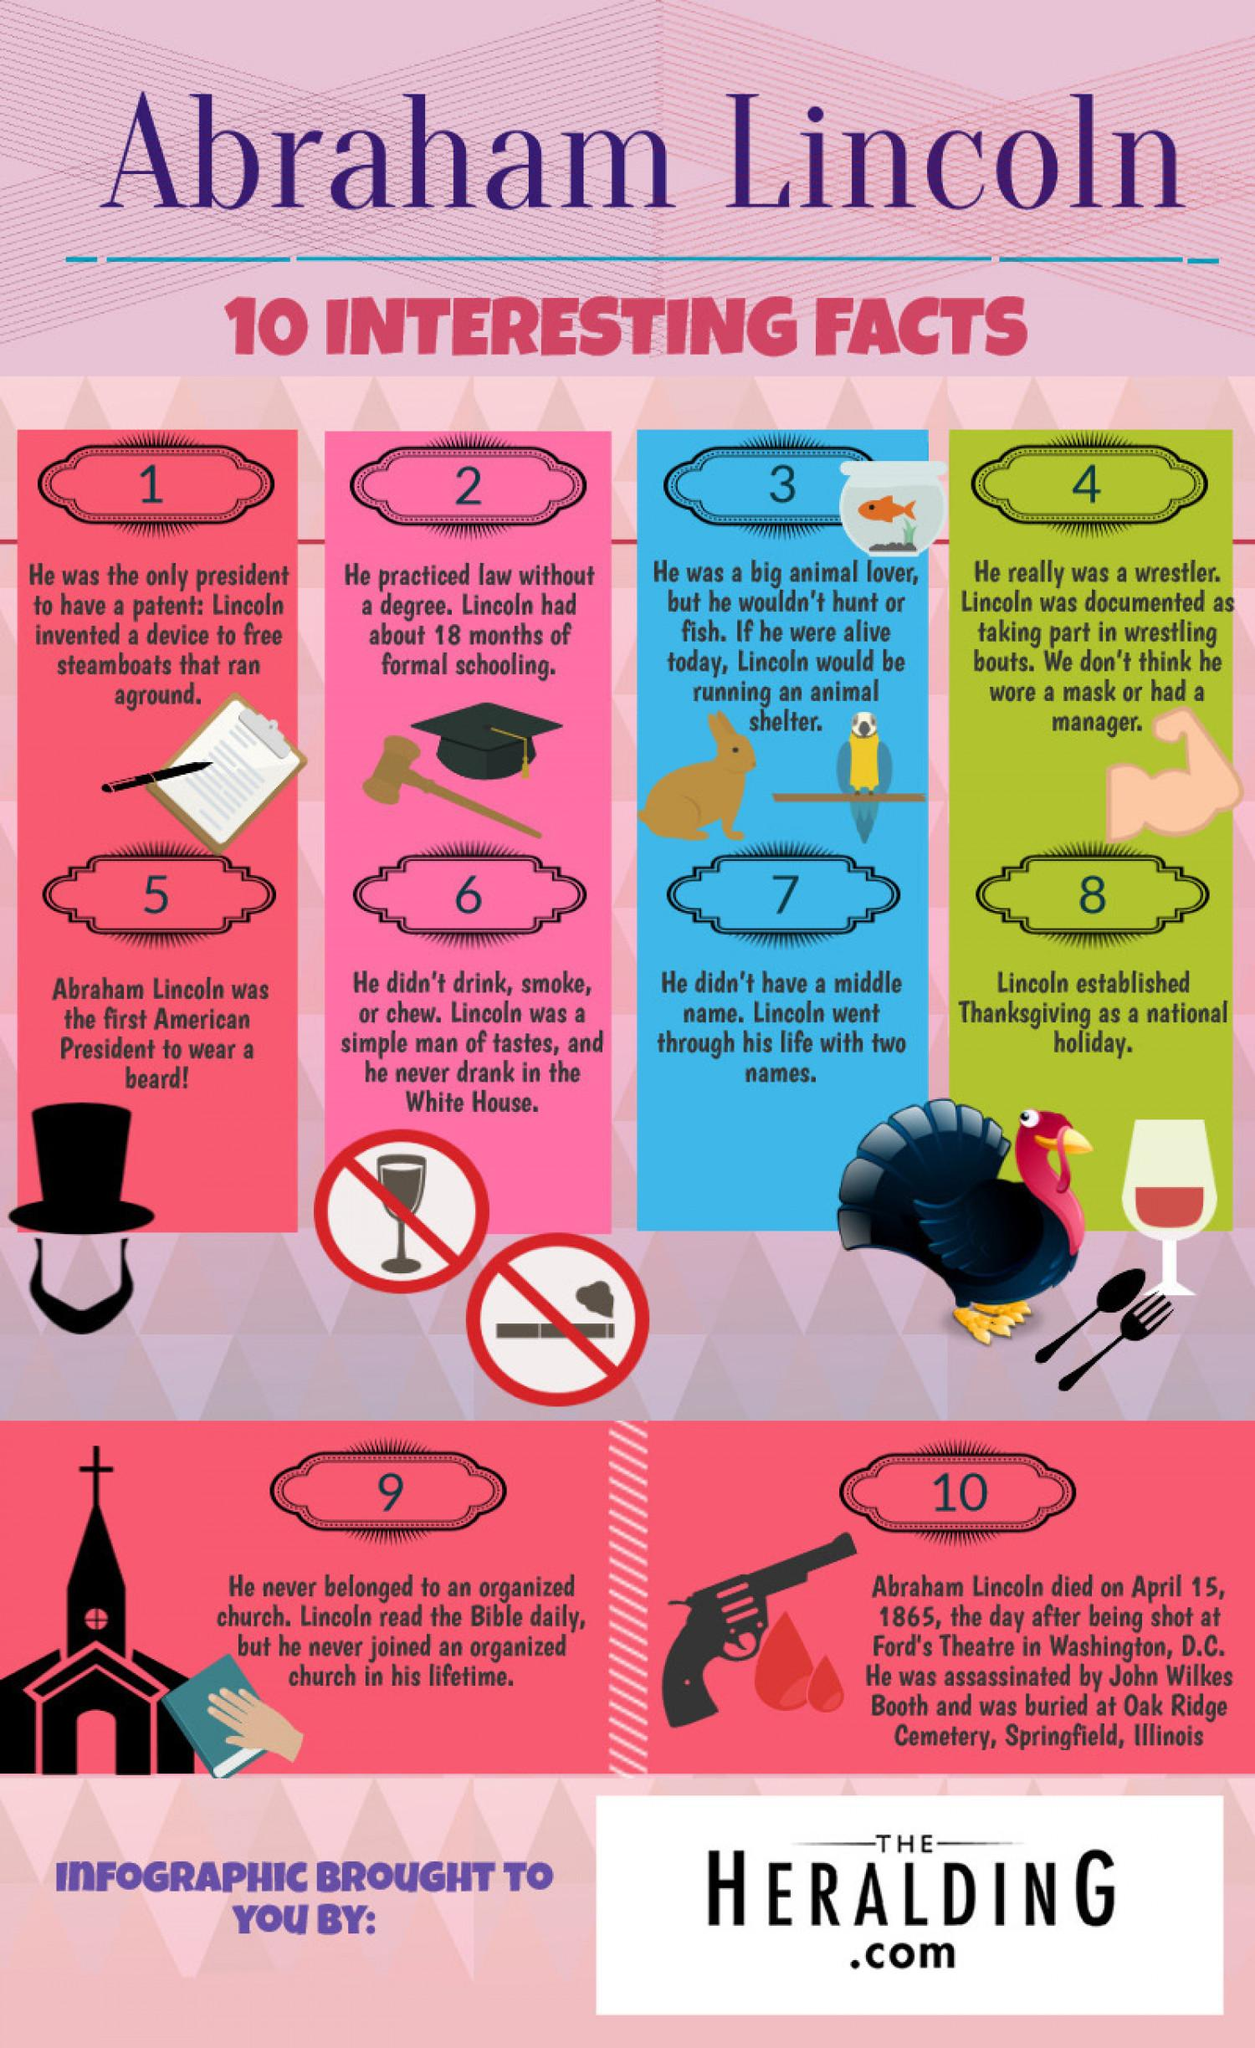Mention a couple of crucial points in this snapshot. Abraham Lincoln was shot dead at Ford's Theatre in Washington, D.C. Abraham Lincoln owned a patent for an invention that allowed steamboats that had run aground to be freed. He invented a device that utilized steam power to lift the boat off the ground and float it back to deeper water. This invention contributed to Lincoln's reputation as an inventor and a leader in the field of steam power technology. The third interesting fact column shows an animal, which is either a rabbit or a rat. The correct answer is a rabbit. Abraham Lincoln had a beard. It is an interesting fact that has been pointed out. 